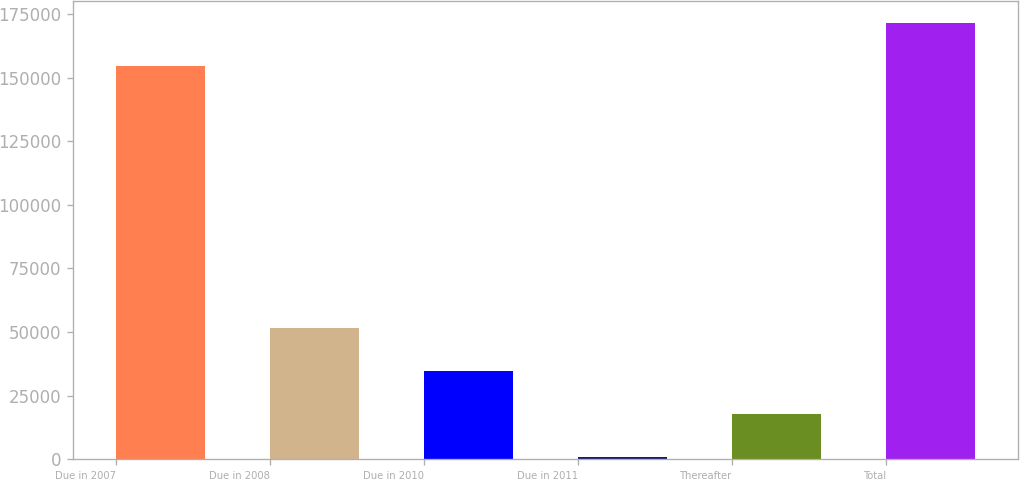Convert chart to OTSL. <chart><loc_0><loc_0><loc_500><loc_500><bar_chart><fcel>Due in 2007<fcel>Due in 2008<fcel>Due in 2010<fcel>Due in 2011<fcel>Thereafter<fcel>Total<nl><fcel>154509<fcel>51663<fcel>34711<fcel>807<fcel>17759<fcel>171461<nl></chart> 